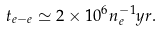Convert formula to latex. <formula><loc_0><loc_0><loc_500><loc_500>t _ { e - e } \simeq 2 \times 1 0 ^ { 6 } n _ { e } ^ { - 1 } y r .</formula> 